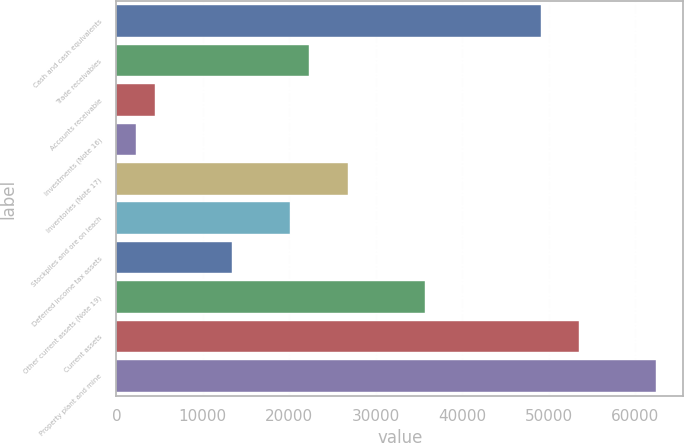<chart> <loc_0><loc_0><loc_500><loc_500><bar_chart><fcel>Cash and cash equivalents<fcel>Trade receivables<fcel>Accounts receivable<fcel>Investments (Note 16)<fcel>Inventories (Note 17)<fcel>Stockpiles and ore on leach<fcel>Deferred income tax assets<fcel>Other current assets (Note 19)<fcel>Current assets<fcel>Property plant and mine<nl><fcel>49042.2<fcel>22299<fcel>4470.2<fcel>2241.6<fcel>26756.2<fcel>20070.4<fcel>13384.6<fcel>35670.6<fcel>53499.4<fcel>62413.8<nl></chart> 